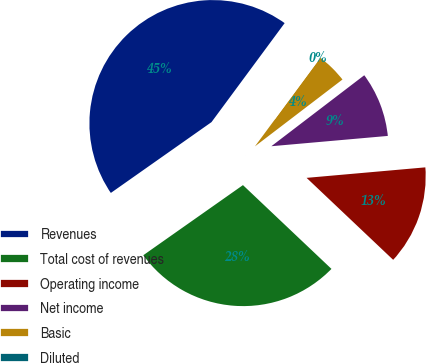<chart> <loc_0><loc_0><loc_500><loc_500><pie_chart><fcel>Revenues<fcel>Total cost of revenues<fcel>Operating income<fcel>Net income<fcel>Basic<fcel>Diluted<nl><fcel>44.89%<fcel>28.18%<fcel>13.47%<fcel>8.98%<fcel>4.49%<fcel>0.0%<nl></chart> 